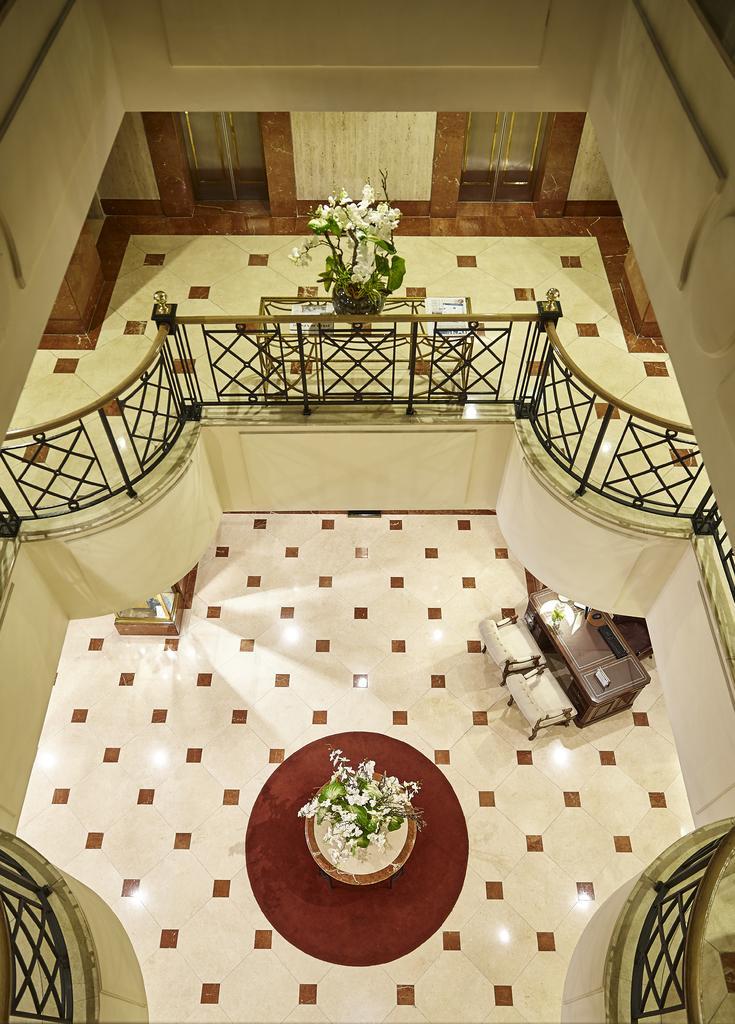Could you give a brief overview of what you see in this image? In this image we can see a room containing the floor, flower pot, table with chairs, fence, wall and the doors. 